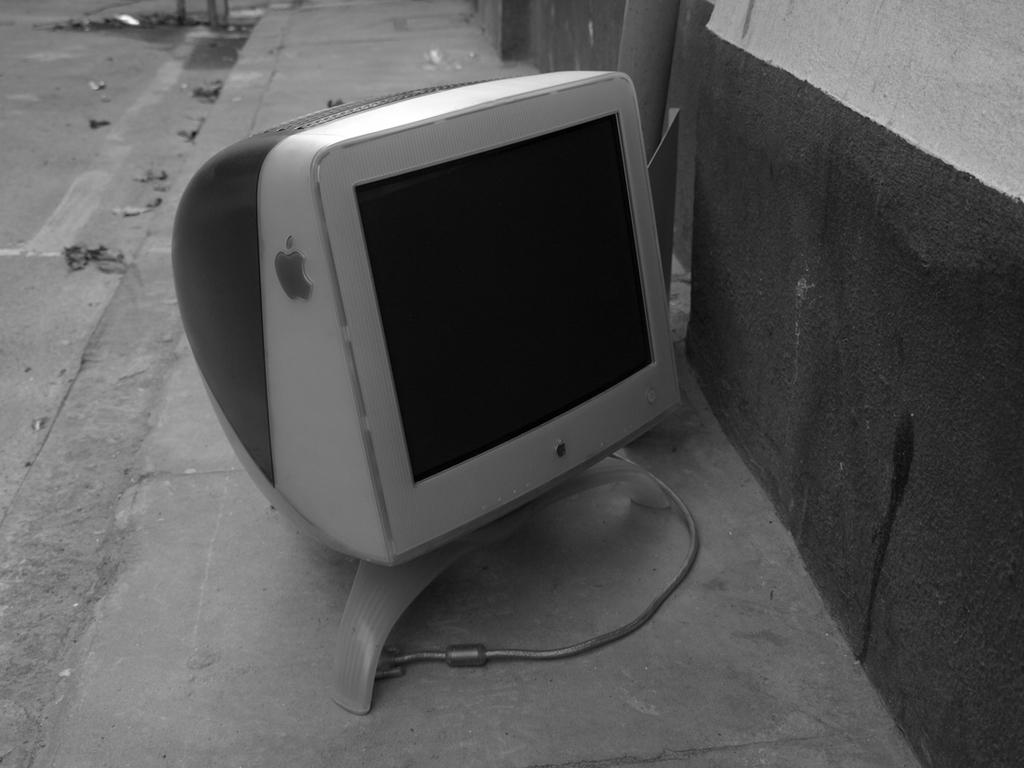What type of monitor is visible in the image? There is a Macintosh monitor in the image. Where is the Macintosh monitor located? The Macintosh monitor is on the surface of the ground. What type of cheese is present on the Macintosh monitor in the image? There is no cheese present on the Macintosh monitor in the image. What type of iron equipment is visible near the Macintosh monitor in the image? There is no iron equipment visible near the Macintosh monitor in the image. 